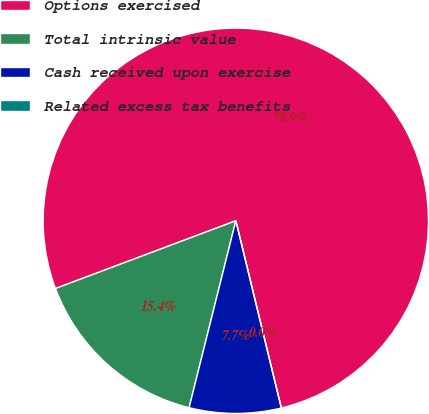Convert chart to OTSL. <chart><loc_0><loc_0><loc_500><loc_500><pie_chart><fcel>Options exercised<fcel>Total intrinsic value<fcel>Cash received upon exercise<fcel>Related excess tax benefits<nl><fcel>76.92%<fcel>15.38%<fcel>7.69%<fcel>0.0%<nl></chart> 